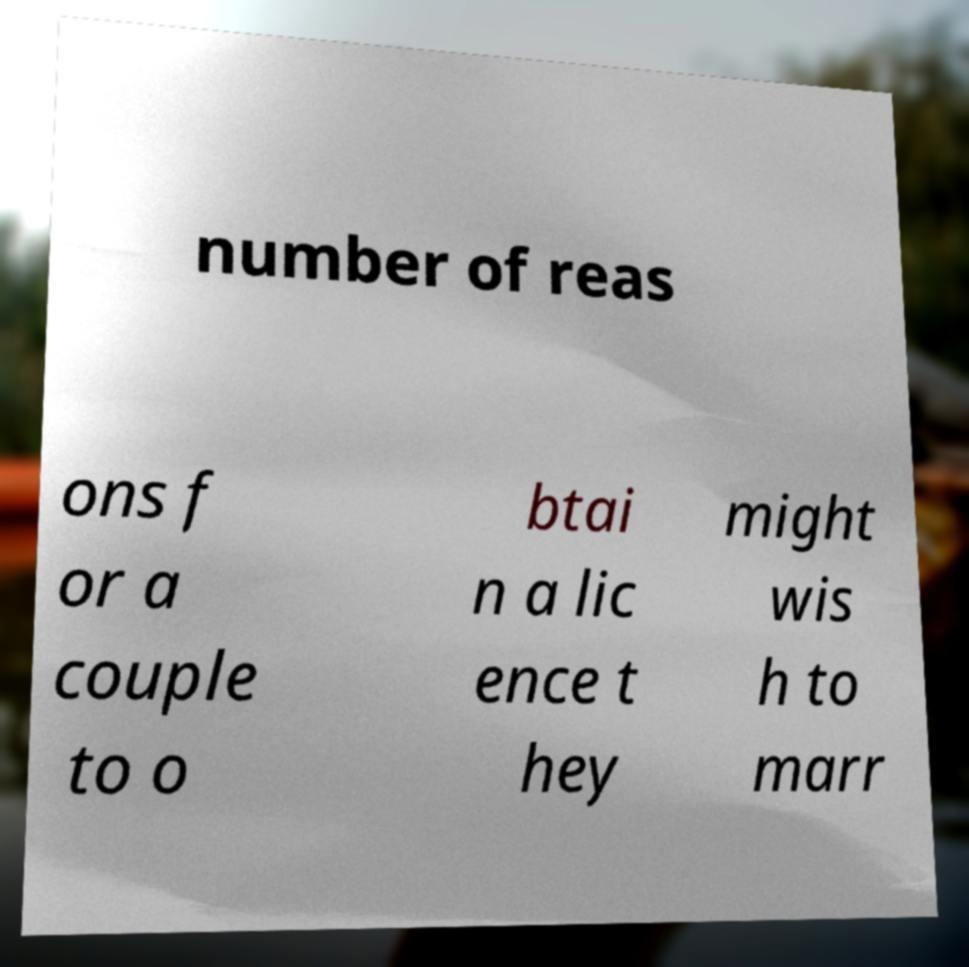I need the written content from this picture converted into text. Can you do that? number of reas ons f or a couple to o btai n a lic ence t hey might wis h to marr 